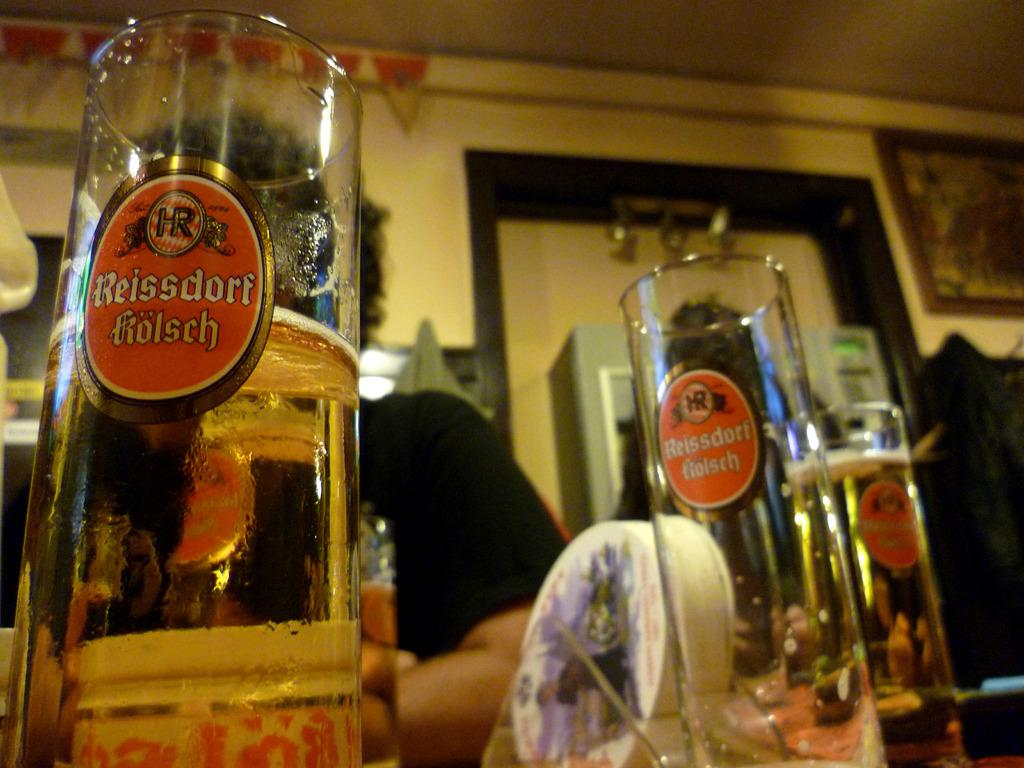<image>
Give a short and clear explanation of the subsequent image. Tall beer steins are labeled Reissdorf Kolsch, one is half full. 